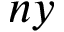<formula> <loc_0><loc_0><loc_500><loc_500>n y</formula> 